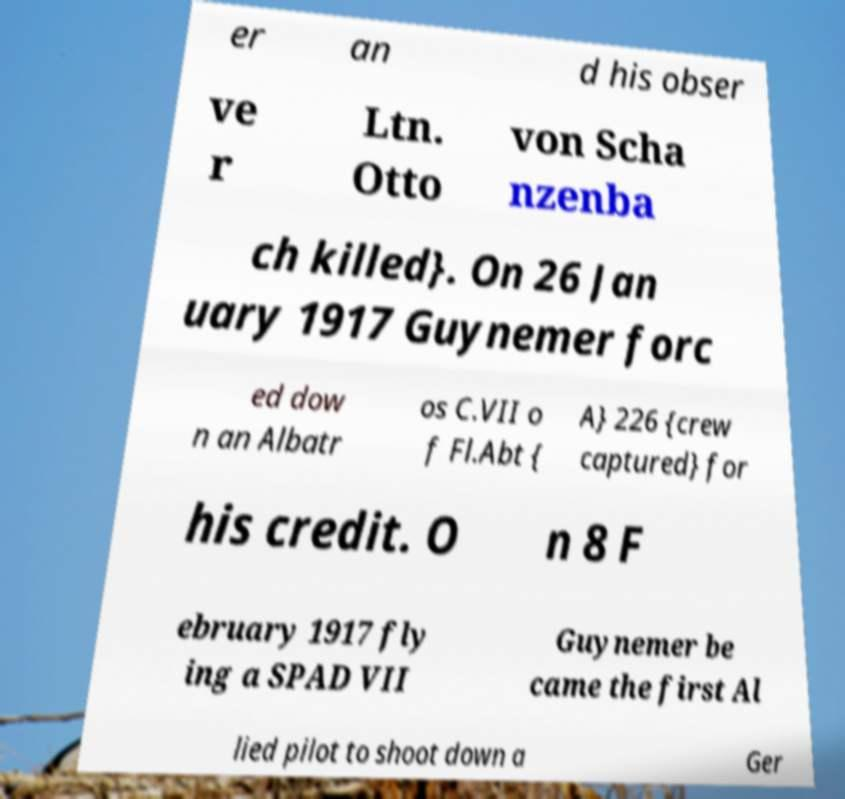I need the written content from this picture converted into text. Can you do that? er an d his obser ve r Ltn. Otto von Scha nzenba ch killed}. On 26 Jan uary 1917 Guynemer forc ed dow n an Albatr os C.VII o f Fl.Abt { A} 226 {crew captured} for his credit. O n 8 F ebruary 1917 fly ing a SPAD VII Guynemer be came the first Al lied pilot to shoot down a Ger 